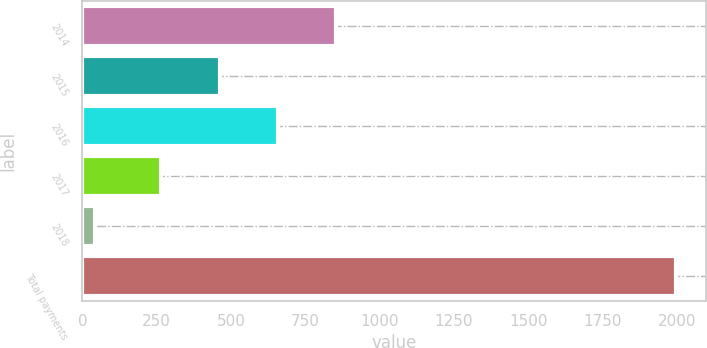Convert chart. <chart><loc_0><loc_0><loc_500><loc_500><bar_chart><fcel>2014<fcel>2015<fcel>2016<fcel>2017<fcel>2018<fcel>Total payments<nl><fcel>853.1<fcel>461.7<fcel>657.4<fcel>266<fcel>41<fcel>1998<nl></chart> 